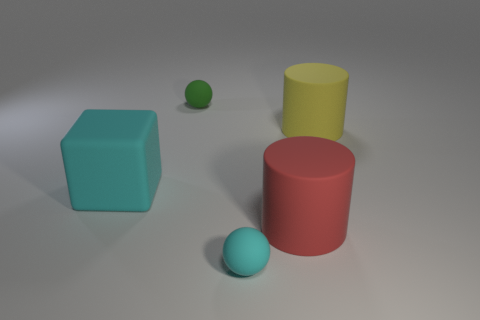Add 3 red objects. How many objects exist? 8 Subtract all blocks. How many objects are left? 4 Add 5 green matte objects. How many green matte objects exist? 6 Subtract 0 brown balls. How many objects are left? 5 Subtract all red rubber objects. Subtract all large cyan rubber cubes. How many objects are left? 3 Add 4 green rubber objects. How many green rubber objects are left? 5 